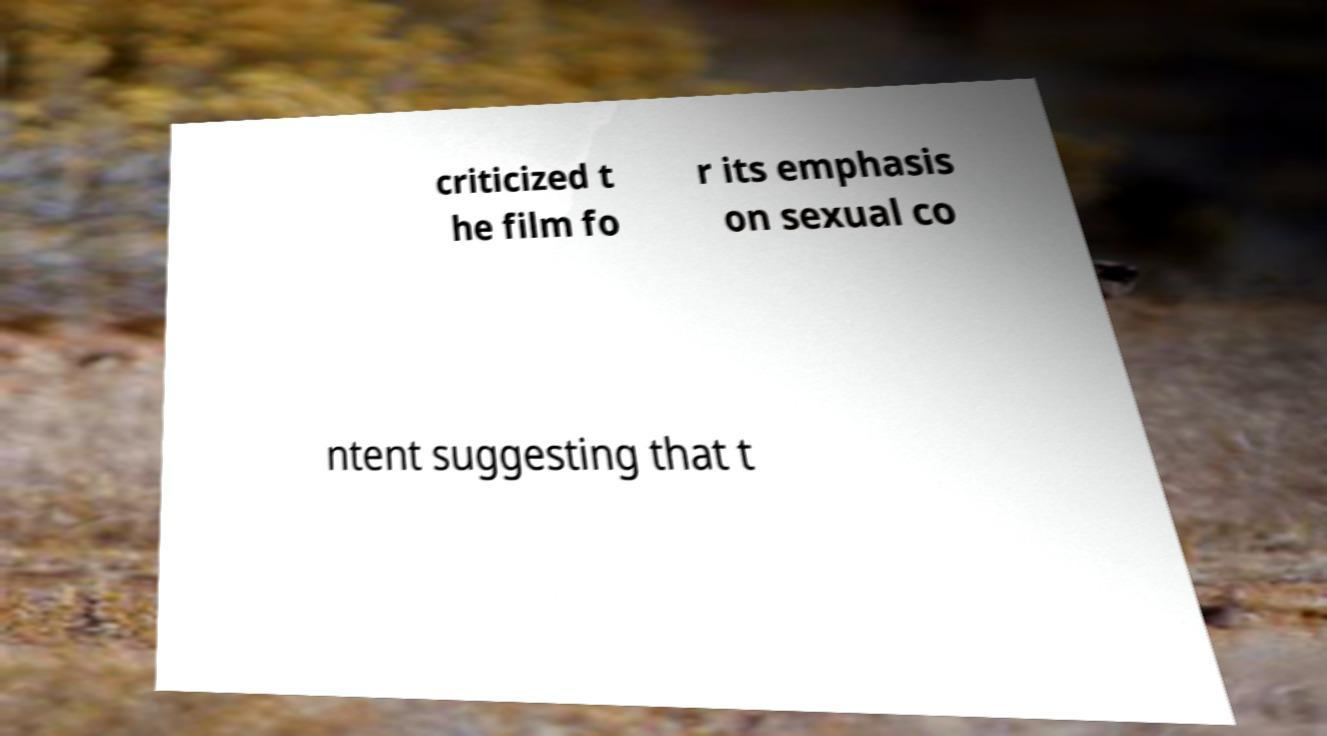Can you accurately transcribe the text from the provided image for me? criticized t he film fo r its emphasis on sexual co ntent suggesting that t 